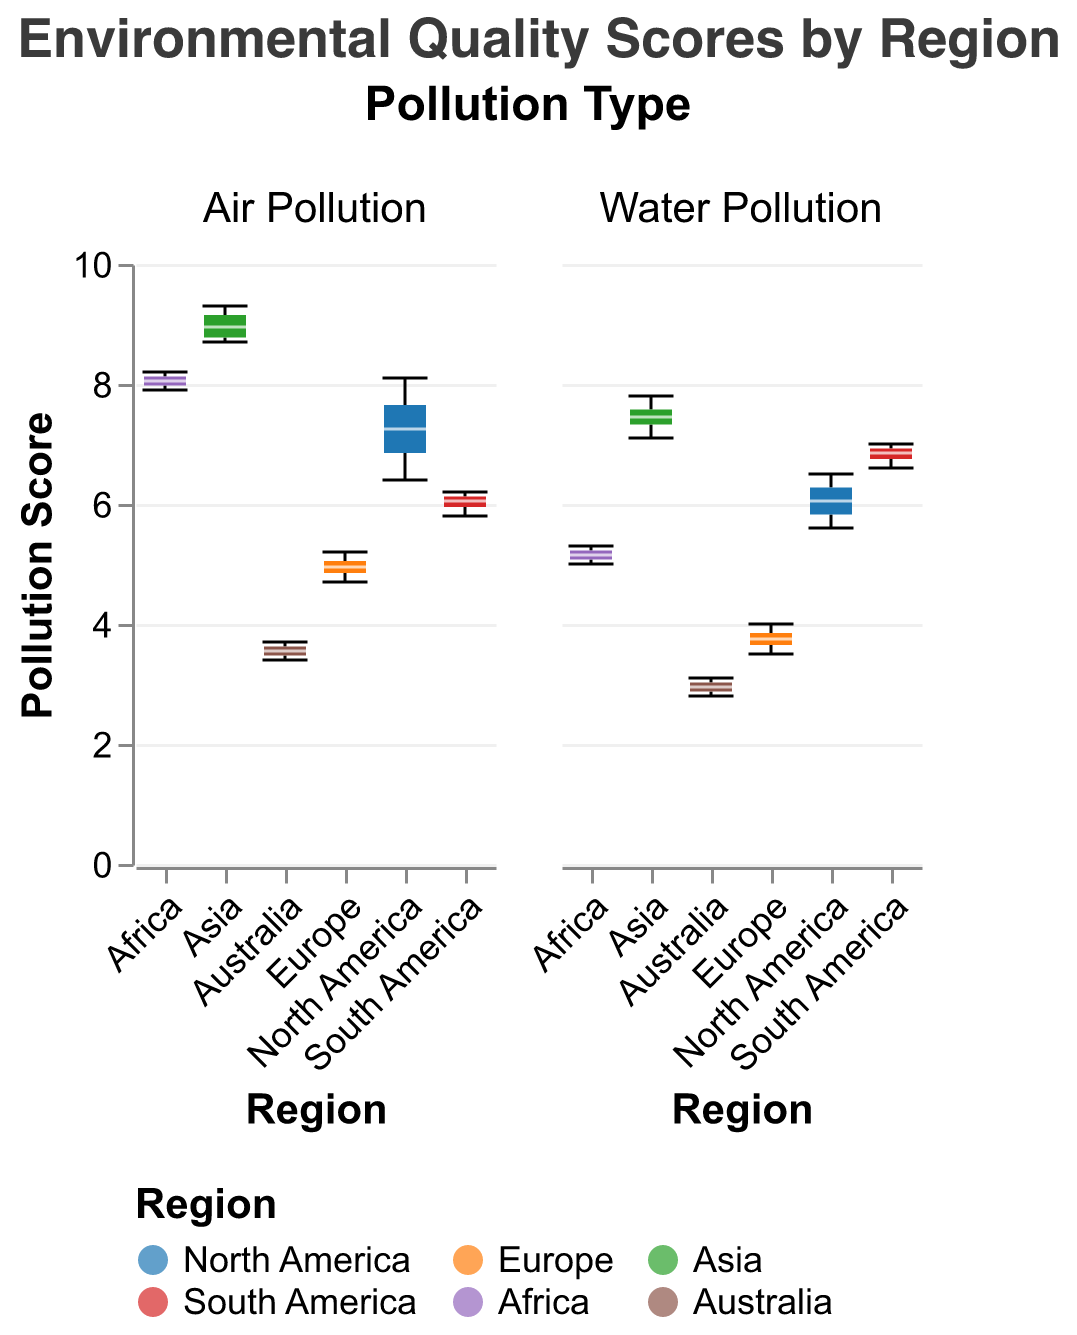What is the title of the figure? The title is displayed at the top of the figure.
Answer: Environmental Quality Scores by Region Which region has the highest median air pollution score? By inspecting the box plot for air pollution, identify the region with the highest median indicated by the central line of the box.
Answer: Asia What is the interquartile range (IQR) of water pollution scores in Europe? Locate the edges of the box plot corresponding to the first (Q1) and third quartiles (Q3) for Europe under water pollution, then compute IQR as Q3-Q1.
Answer: 0.5 (3.7 to 4.2) Compare the median air pollution scores between North America and Australia. Which has the lower score and by how much? Find the median values labeled for both North America and Australia in the air pollution box plot and calculate the difference.
Answer: Australia, lower by 3.5 What is the range of water pollution scores in South America? Identify the minimum and maximum values (whiskers) in the box plot for South America under water pollution, then calculate the difference between them.
Answer: 0.4 (6.6 to 7.0) Which region has the smallest variability in air pollution scores? The smallest variability corresponds to the shortest IQR (the box length) in the air pollution subplot.
Answer: Australia In which region is the median water pollution score closest to the median air pollution score of the same region? Compare the medians within each region for water and air pollution, and identify the region with the closest values.
Answer: Africa Which type of pollution generally scores higher across most regions, air or water? Compare the median values for both types of pollution across all regions.
Answer: Air Pollution How does the variability in water pollution scores in Asia compare to that in North America? Compare the lengths of the boxes in the water pollution subplots for Asia and North America to assess variability.
Answer: Asia has higher variability Is there any region where the water pollution score is more consistent (less variability) than the air pollution score? Compare the lengths of the boxes (IQRs) within each region to identify any region where the water pollution score box is shorter.
Answer: Australia 